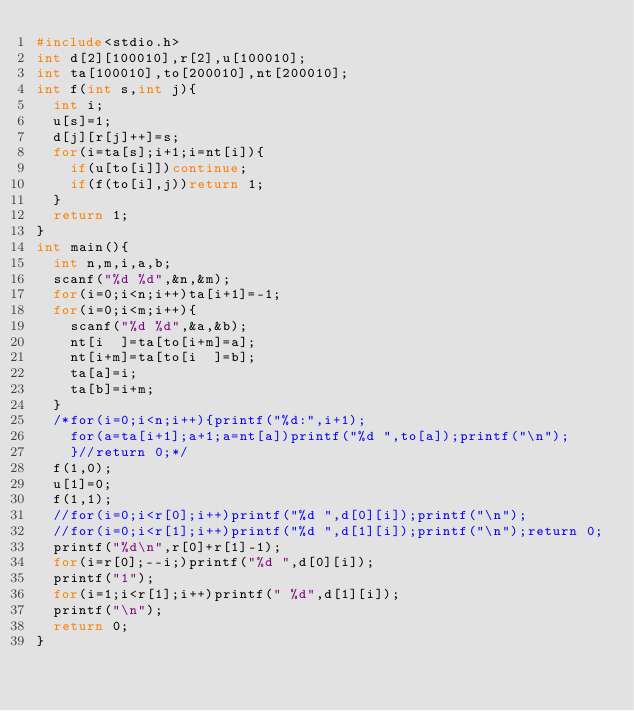<code> <loc_0><loc_0><loc_500><loc_500><_C_>#include<stdio.h>
int d[2][100010],r[2],u[100010];
int ta[100010],to[200010],nt[200010];
int f(int s,int j){
  int i;
  u[s]=1;
  d[j][r[j]++]=s;
  for(i=ta[s];i+1;i=nt[i]){
    if(u[to[i]])continue;
    if(f(to[i],j))return 1;
  }
  return 1;
}
int main(){
  int n,m,i,a,b;
  scanf("%d %d",&n,&m);
  for(i=0;i<n;i++)ta[i+1]=-1;
  for(i=0;i<m;i++){
    scanf("%d %d",&a,&b);
    nt[i  ]=ta[to[i+m]=a];
    nt[i+m]=ta[to[i  ]=b];
    ta[a]=i;
    ta[b]=i+m;
  }
  /*for(i=0;i<n;i++){printf("%d:",i+1);
    for(a=ta[i+1];a+1;a=nt[a])printf("%d ",to[a]);printf("\n");
    }//return 0;*/
  f(1,0);
  u[1]=0;
  f(1,1);
  //for(i=0;i<r[0];i++)printf("%d ",d[0][i]);printf("\n");
  //for(i=0;i<r[1];i++)printf("%d ",d[1][i]);printf("\n");return 0;
  printf("%d\n",r[0]+r[1]-1);
  for(i=r[0];--i;)printf("%d ",d[0][i]);
  printf("1");
  for(i=1;i<r[1];i++)printf(" %d",d[1][i]);
  printf("\n");
  return 0;
}
</code> 